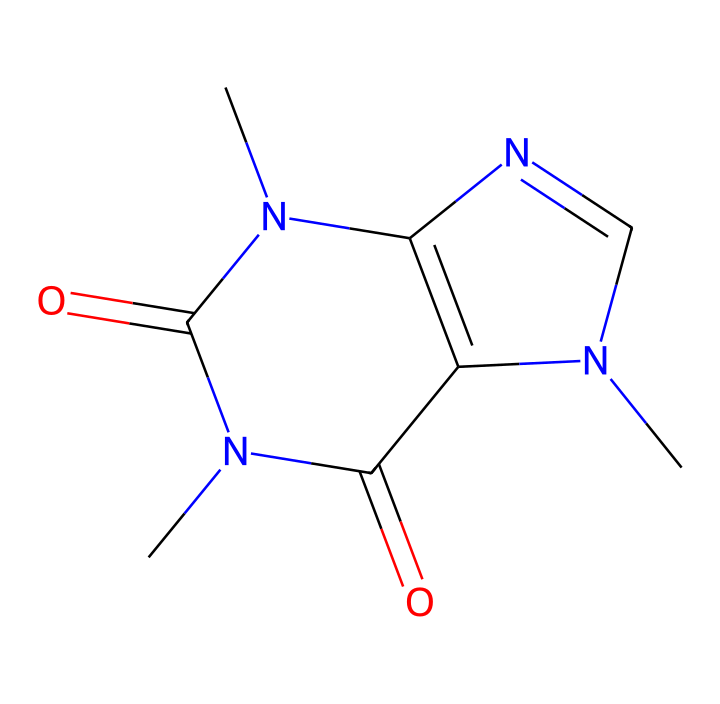What is the molecular formula of this compound? By analyzing the SMILES representation, we can count the number of each type of atom present. The presence of 'C', 'N', and 'O' indicates carbon, nitrogen, and oxygen atoms. When counted from the structure, we find there are 8 Carbon atoms, 10 Hydrogen atoms, 4 Nitrogen atoms, and 2 Oxygen atoms, which composes the molecular formula C8H10N4O2.
Answer: C8H10N4O2 How many nitrogen atoms are present in the structure? From the SMILES representation, we can clearly identify the number of 'N' symbols in the sequence. On counting these 'N', there are 4 nitrogen atoms present in the molecular structure.
Answer: 4 Is this compound a strong or mild base? Caffeine is known to be a mild base due to its ability to accept protons, which is generally determined by its structure that includes nitrogen atoms. Given its properties and common designation in chemistry, it confirms it as a mild base.
Answer: mild base What type of functional groups are present in this compound? Looking at the SMILES representation, we can observe carbonyl (C=O) and amine (N-H) functional groups. The 'C(=O)' indicates the presence of a carbonyl group, while the nitrogen presence implies amine functionality. Thus, this compound contains both carbonyl and amine functional groups.
Answer: carbonyl and amine How does the structure contribute to its solubility in water? The presence of multiple nitrogen atoms in the caffeine structure enhances its polarity, allowing better interaction with water molecules. This makes caffeine relatively soluble in water, as polar molecules typically dissolve well in polar solvents.
Answer: polarity What is the key feature that makes caffeine a stimulant? The arrangement of nitrogen atoms in the structure influences the binding of caffeine to adenosine receptors in the brain, which is crucial for its stimulant effect, as it blocks adenosine—a neurotransmitter that promotes sleep.
Answer: nitrogen arrangement 